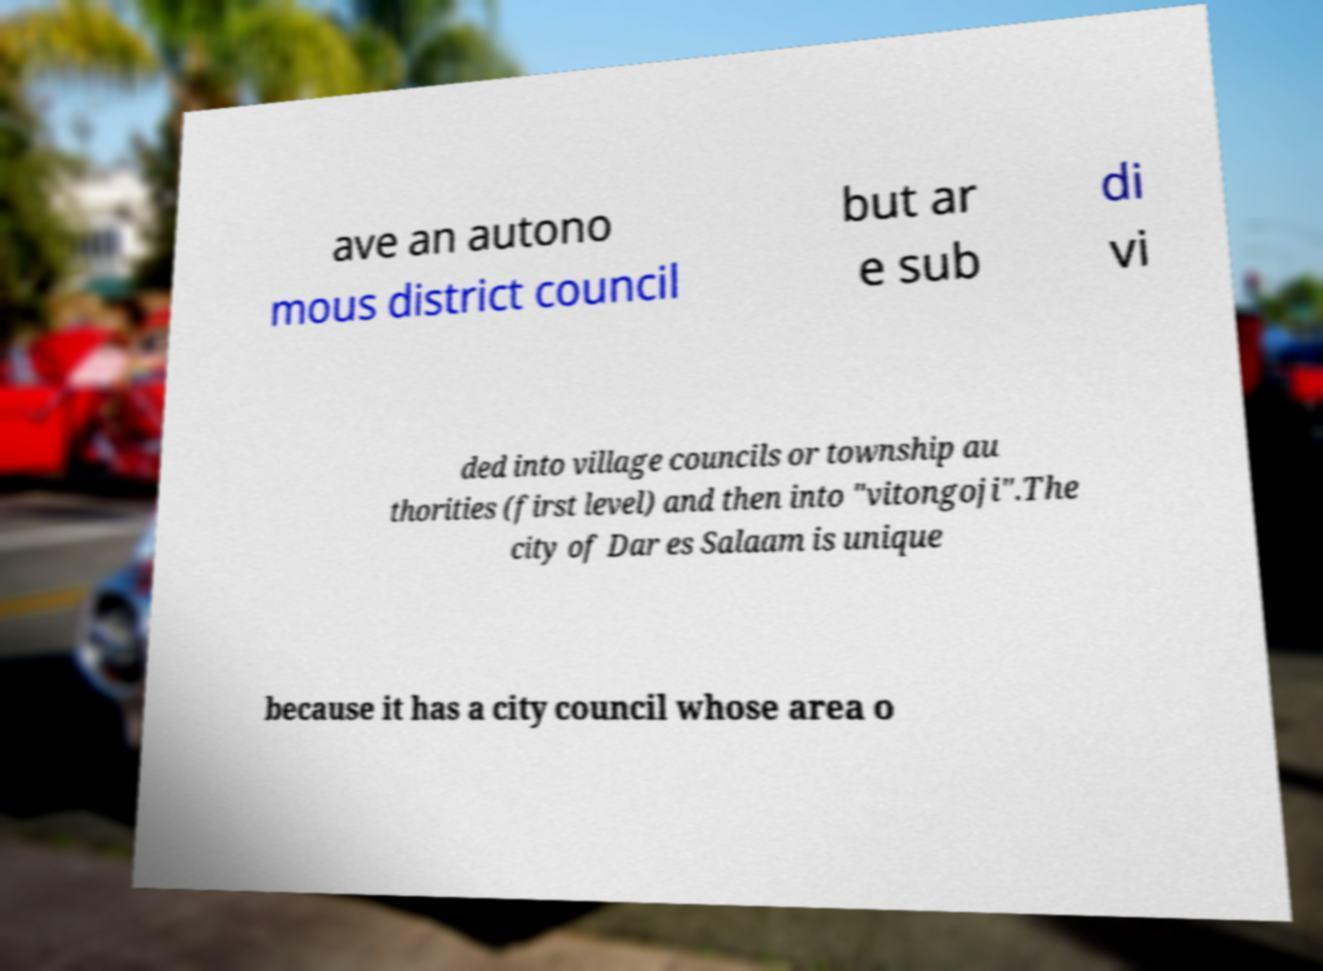Could you extract and type out the text from this image? ave an autono mous district council but ar e sub di vi ded into village councils or township au thorities (first level) and then into "vitongoji".The city of Dar es Salaam is unique because it has a city council whose area o 